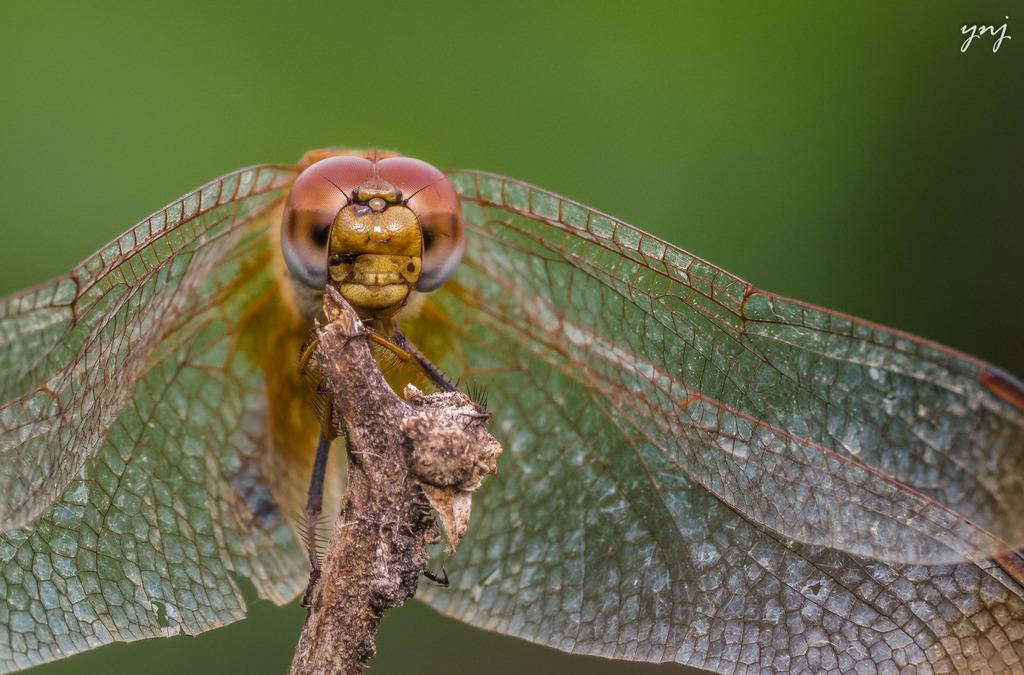What insect is present in the image? There is a dragonfly in the image. What is the dragonfly resting on? The dragonfly is on a dried plant. Can you describe the background of the image? The background of the image is blurred. How many deer can be seen in the image? There are no deer present in the image; it features a dragonfly on a dried plant. Are there any rabbits visible in the image? There are no rabbits present in the image. 